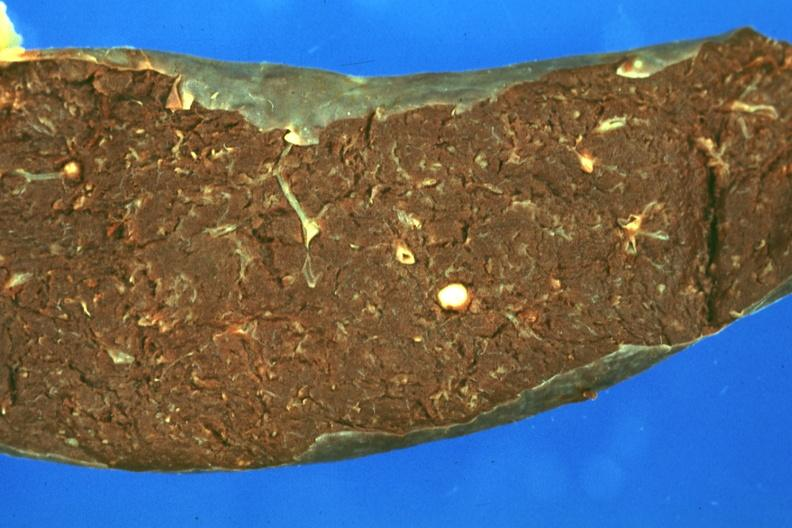what is present?
Answer the question using a single word or phrase. Granuloma 